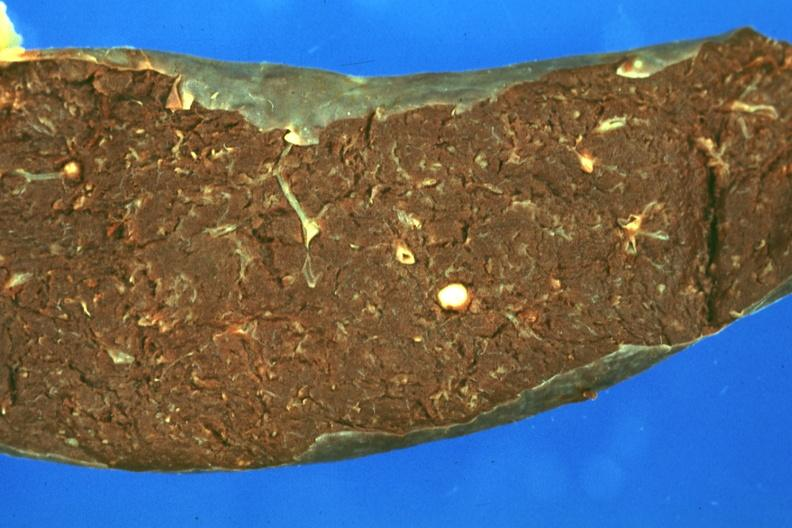what is present?
Answer the question using a single word or phrase. Granuloma 